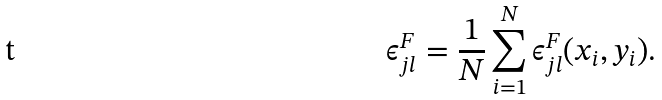Convert formula to latex. <formula><loc_0><loc_0><loc_500><loc_500>\epsilon ^ { F } _ { j l } = \frac { 1 } { N } \sum _ { i = 1 } ^ { N } \epsilon ^ { F } _ { j l } ( x _ { i } , y _ { i } ) .</formula> 